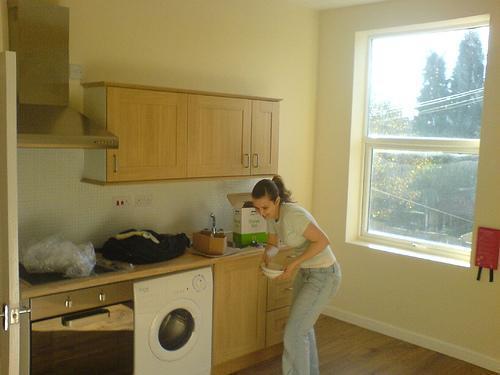How many windows are there?
Give a very brief answer. 1. 